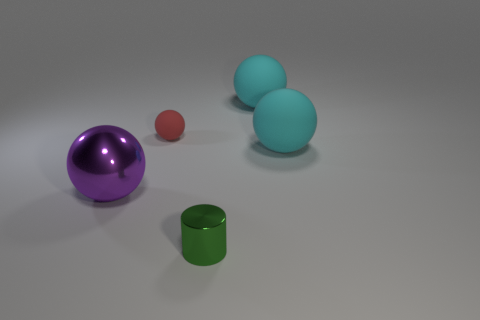How does the arrangement of the objects affect the composition of the image? The arrangement of the objects creates a balanced composition. The varying sizes and distances between objects lead the viewer's eye through the image, from the largest object to the small one, creating a sense of depth and perspective. 